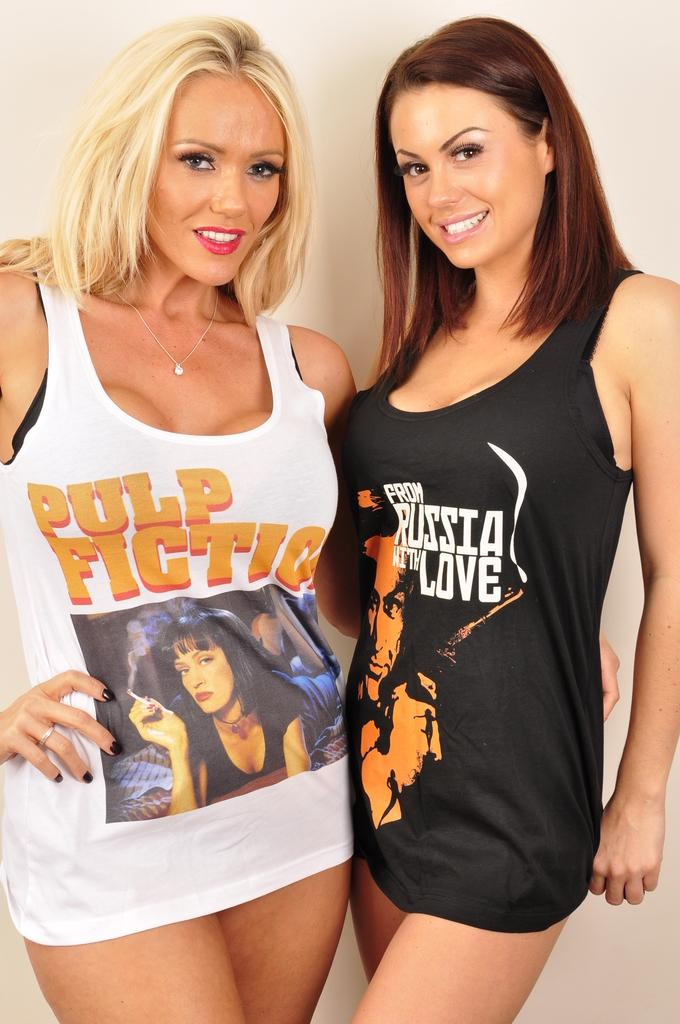<image>
Describe the image concisely. Two girls are wearing tank tops that advertise movies, on being Pulp Fiction. 